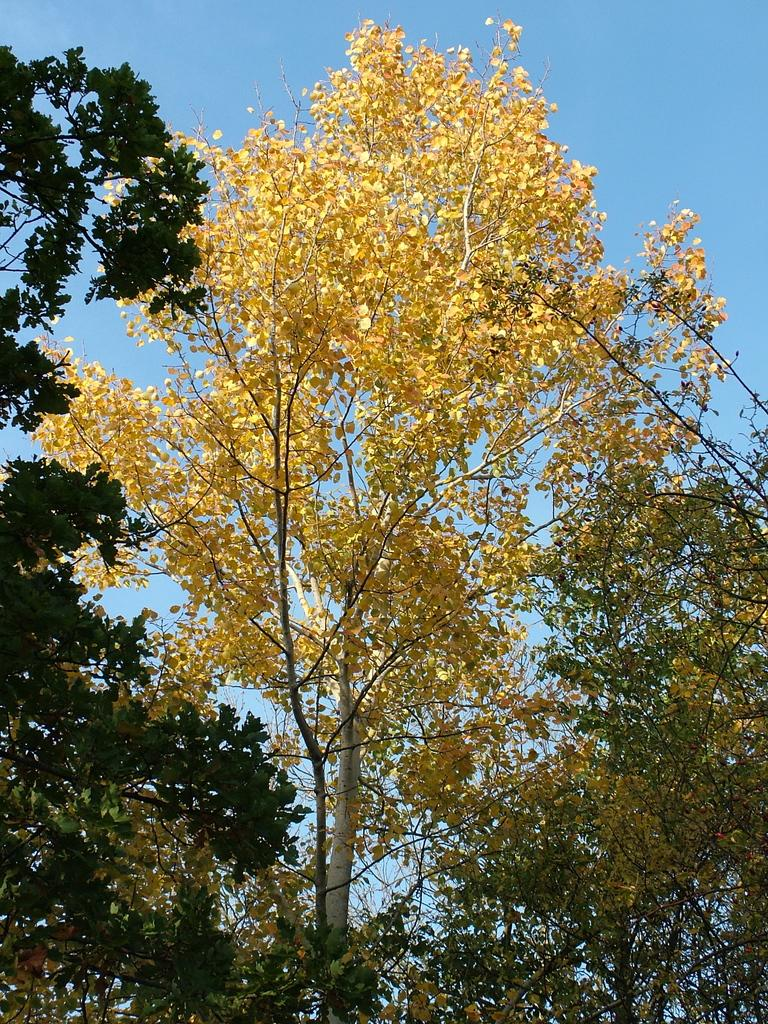What type of vegetation is in the foreground of the image? There are trees in the foreground of the image. What is visible in the background of the image? The background of the image is the sky. How many crackers are visible in the image? There are no crackers present in the image. What type of coach can be seen driving through the trees in the image? There is no coach or vehicle visible in the image; it only features trees in the foreground and the sky in the background. 